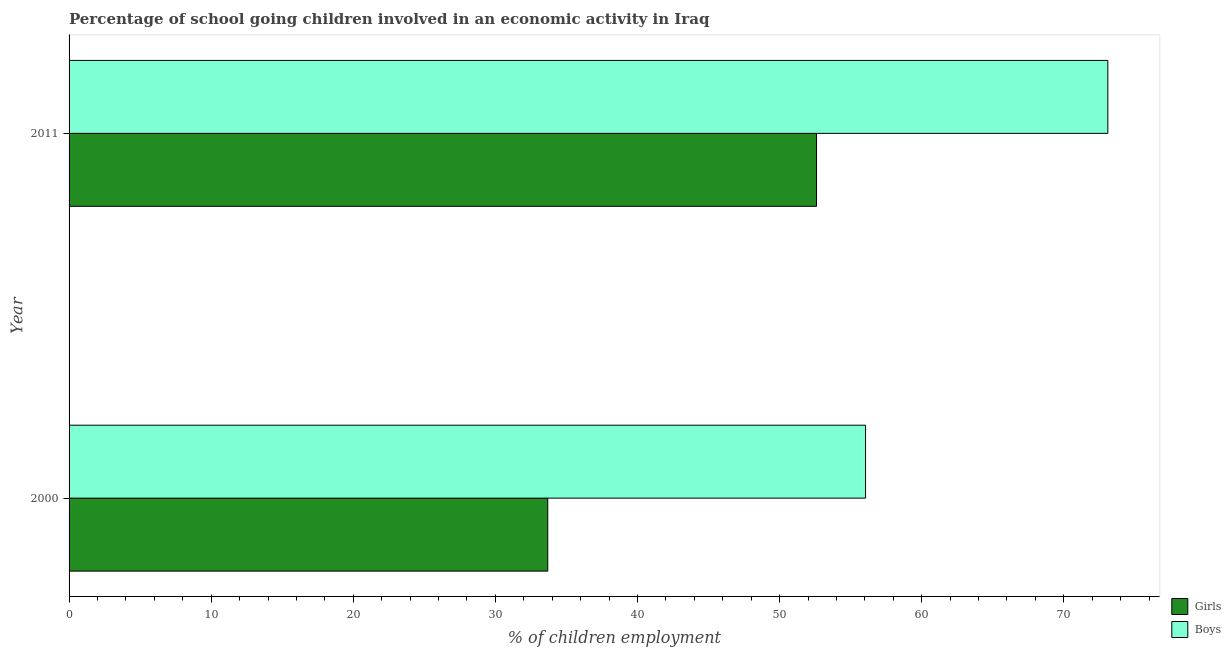Are the number of bars per tick equal to the number of legend labels?
Keep it short and to the point. Yes. How many bars are there on the 2nd tick from the bottom?
Your answer should be very brief. 2. In how many cases, is the number of bars for a given year not equal to the number of legend labels?
Provide a short and direct response. 0. What is the percentage of school going girls in 2000?
Ensure brevity in your answer.  33.69. Across all years, what is the maximum percentage of school going boys?
Your answer should be very brief. 73.1. Across all years, what is the minimum percentage of school going girls?
Offer a terse response. 33.69. What is the total percentage of school going girls in the graph?
Offer a very short reply. 86.29. What is the difference between the percentage of school going girls in 2000 and that in 2011?
Give a very brief answer. -18.91. What is the difference between the percentage of school going girls in 2000 and the percentage of school going boys in 2011?
Make the answer very short. -39.41. What is the average percentage of school going girls per year?
Keep it short and to the point. 43.14. In the year 2000, what is the difference between the percentage of school going boys and percentage of school going girls?
Offer a terse response. 22.36. In how many years, is the percentage of school going girls greater than 10 %?
Provide a succinct answer. 2. What is the ratio of the percentage of school going girls in 2000 to that in 2011?
Keep it short and to the point. 0.64. In how many years, is the percentage of school going boys greater than the average percentage of school going boys taken over all years?
Give a very brief answer. 1. What does the 2nd bar from the top in 2000 represents?
Offer a very short reply. Girls. What does the 2nd bar from the bottom in 2000 represents?
Make the answer very short. Boys. Are all the bars in the graph horizontal?
Offer a terse response. Yes. What is the difference between two consecutive major ticks on the X-axis?
Ensure brevity in your answer.  10. Are the values on the major ticks of X-axis written in scientific E-notation?
Keep it short and to the point. No. Does the graph contain grids?
Offer a terse response. No. How are the legend labels stacked?
Offer a very short reply. Vertical. What is the title of the graph?
Your answer should be compact. Percentage of school going children involved in an economic activity in Iraq. What is the label or title of the X-axis?
Give a very brief answer. % of children employment. What is the label or title of the Y-axis?
Provide a succinct answer. Year. What is the % of children employment in Girls in 2000?
Offer a very short reply. 33.69. What is the % of children employment in Boys in 2000?
Provide a succinct answer. 56.05. What is the % of children employment in Girls in 2011?
Offer a very short reply. 52.6. What is the % of children employment of Boys in 2011?
Ensure brevity in your answer.  73.1. Across all years, what is the maximum % of children employment of Girls?
Keep it short and to the point. 52.6. Across all years, what is the maximum % of children employment of Boys?
Make the answer very short. 73.1. Across all years, what is the minimum % of children employment in Girls?
Make the answer very short. 33.69. Across all years, what is the minimum % of children employment of Boys?
Your response must be concise. 56.05. What is the total % of children employment of Girls in the graph?
Ensure brevity in your answer.  86.29. What is the total % of children employment in Boys in the graph?
Make the answer very short. 129.15. What is the difference between the % of children employment in Girls in 2000 and that in 2011?
Provide a short and direct response. -18.91. What is the difference between the % of children employment of Boys in 2000 and that in 2011?
Your answer should be compact. -17.05. What is the difference between the % of children employment in Girls in 2000 and the % of children employment in Boys in 2011?
Provide a succinct answer. -39.41. What is the average % of children employment of Girls per year?
Provide a succinct answer. 43.14. What is the average % of children employment in Boys per year?
Provide a succinct answer. 64.58. In the year 2000, what is the difference between the % of children employment of Girls and % of children employment of Boys?
Your response must be concise. -22.36. In the year 2011, what is the difference between the % of children employment of Girls and % of children employment of Boys?
Offer a very short reply. -20.5. What is the ratio of the % of children employment of Girls in 2000 to that in 2011?
Ensure brevity in your answer.  0.64. What is the ratio of the % of children employment in Boys in 2000 to that in 2011?
Provide a succinct answer. 0.77. What is the difference between the highest and the second highest % of children employment of Girls?
Offer a terse response. 18.91. What is the difference between the highest and the second highest % of children employment in Boys?
Ensure brevity in your answer.  17.05. What is the difference between the highest and the lowest % of children employment in Girls?
Give a very brief answer. 18.91. What is the difference between the highest and the lowest % of children employment of Boys?
Ensure brevity in your answer.  17.05. 